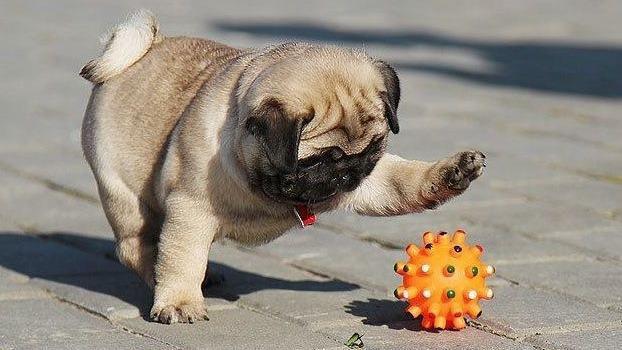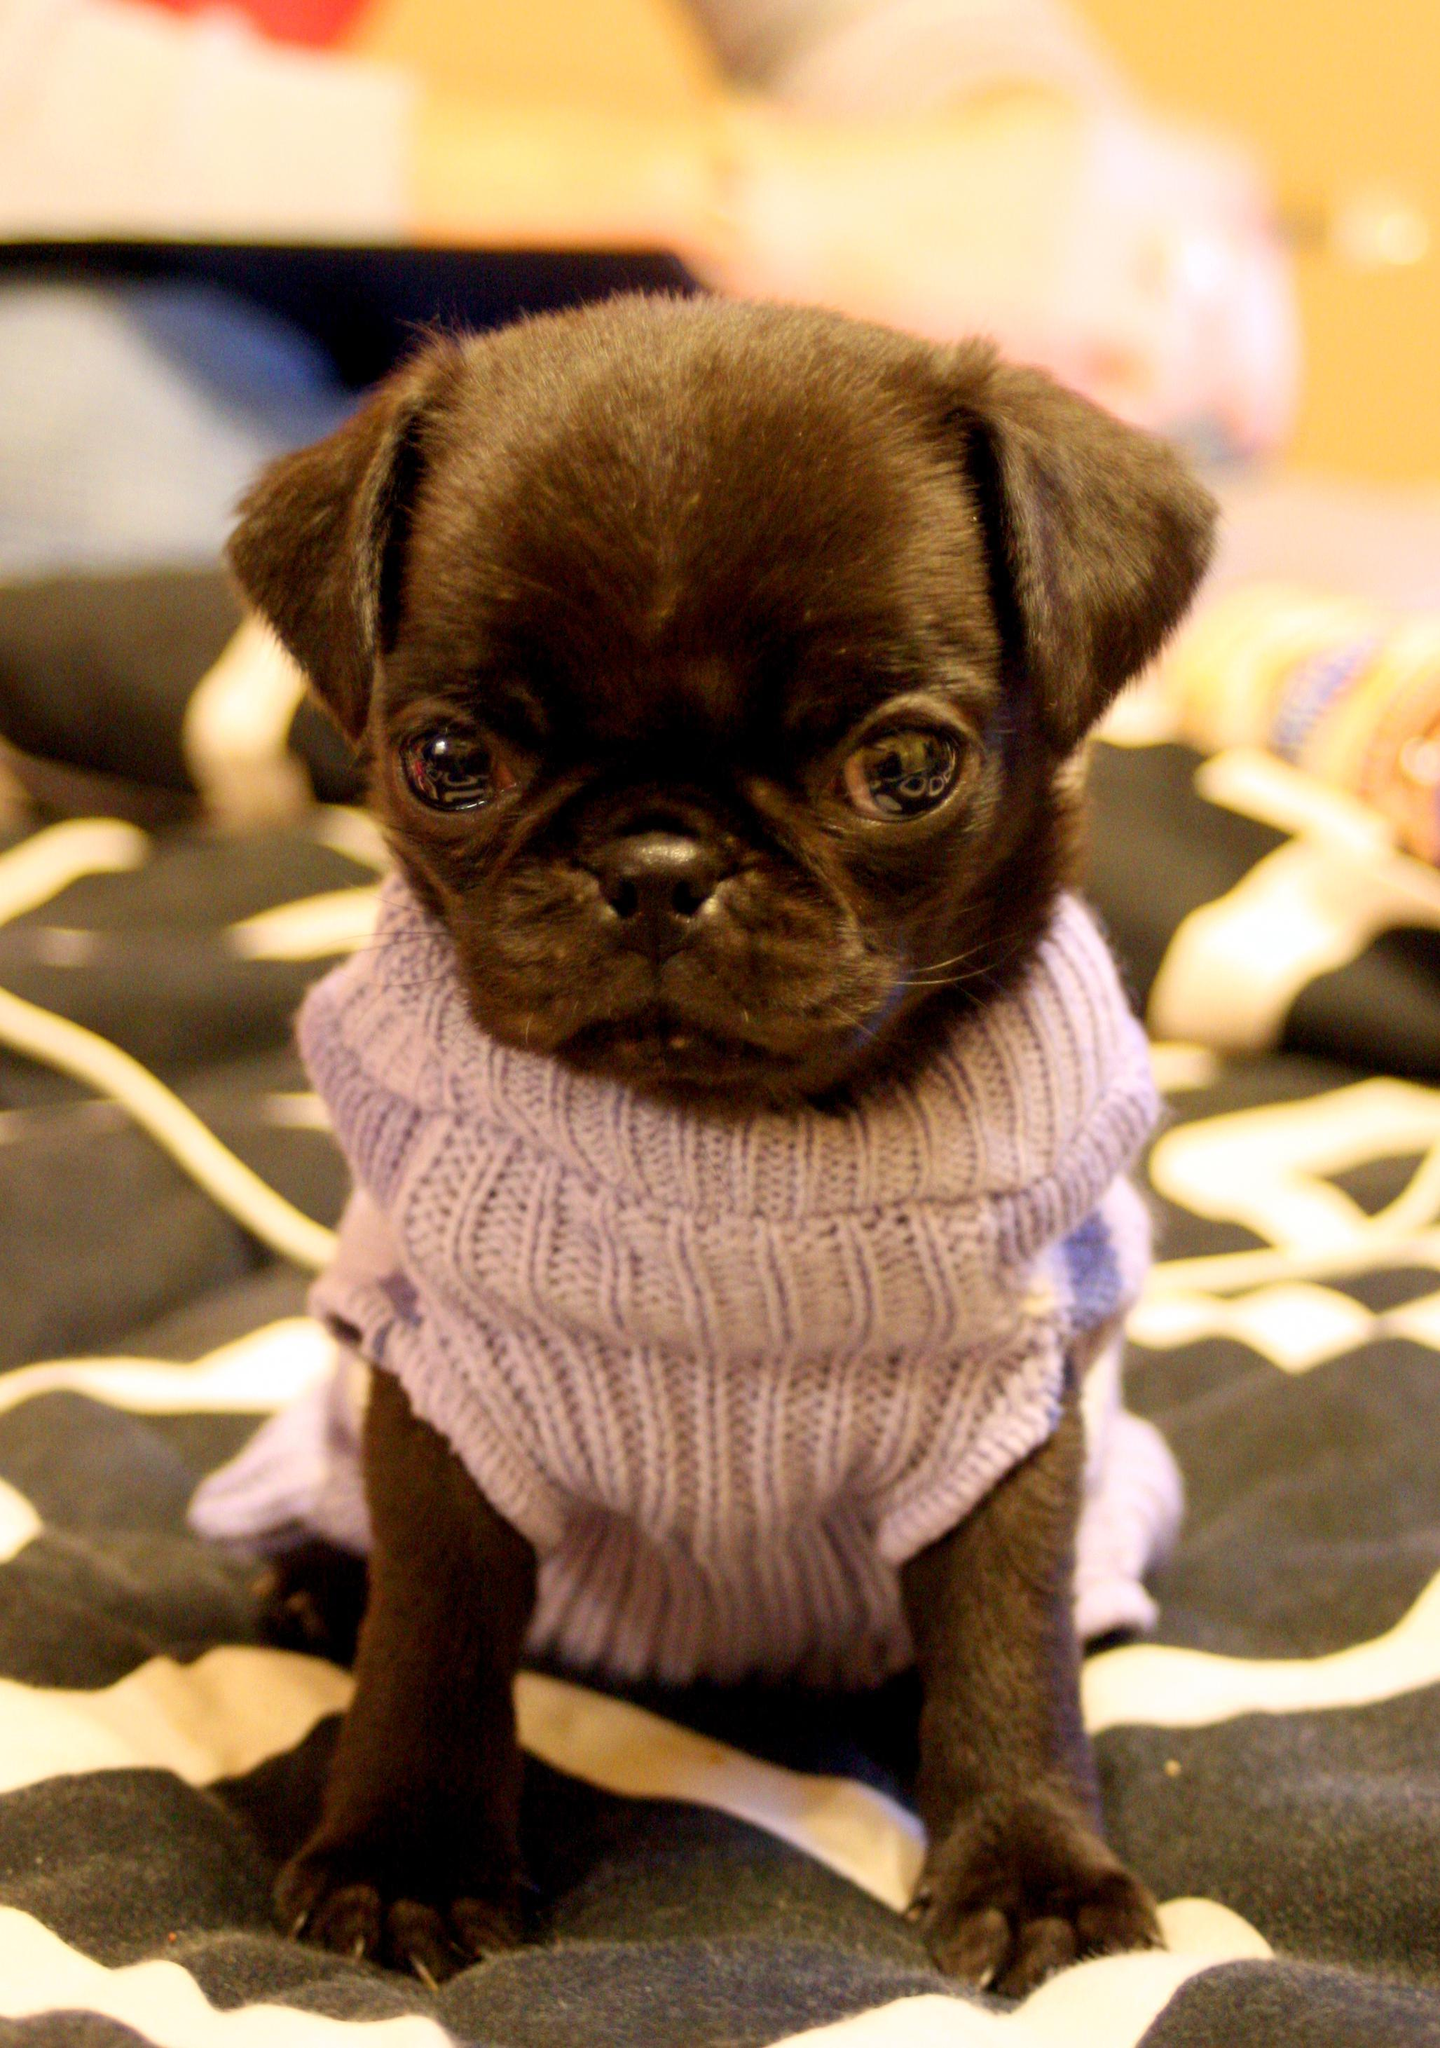The first image is the image on the left, the second image is the image on the right. Considering the images on both sides, is "There are at most two dogs." valid? Answer yes or no. Yes. The first image is the image on the left, the second image is the image on the right. Examine the images to the left and right. Is the description "The right image contains exactly three pug dogs." accurate? Answer yes or no. No. 